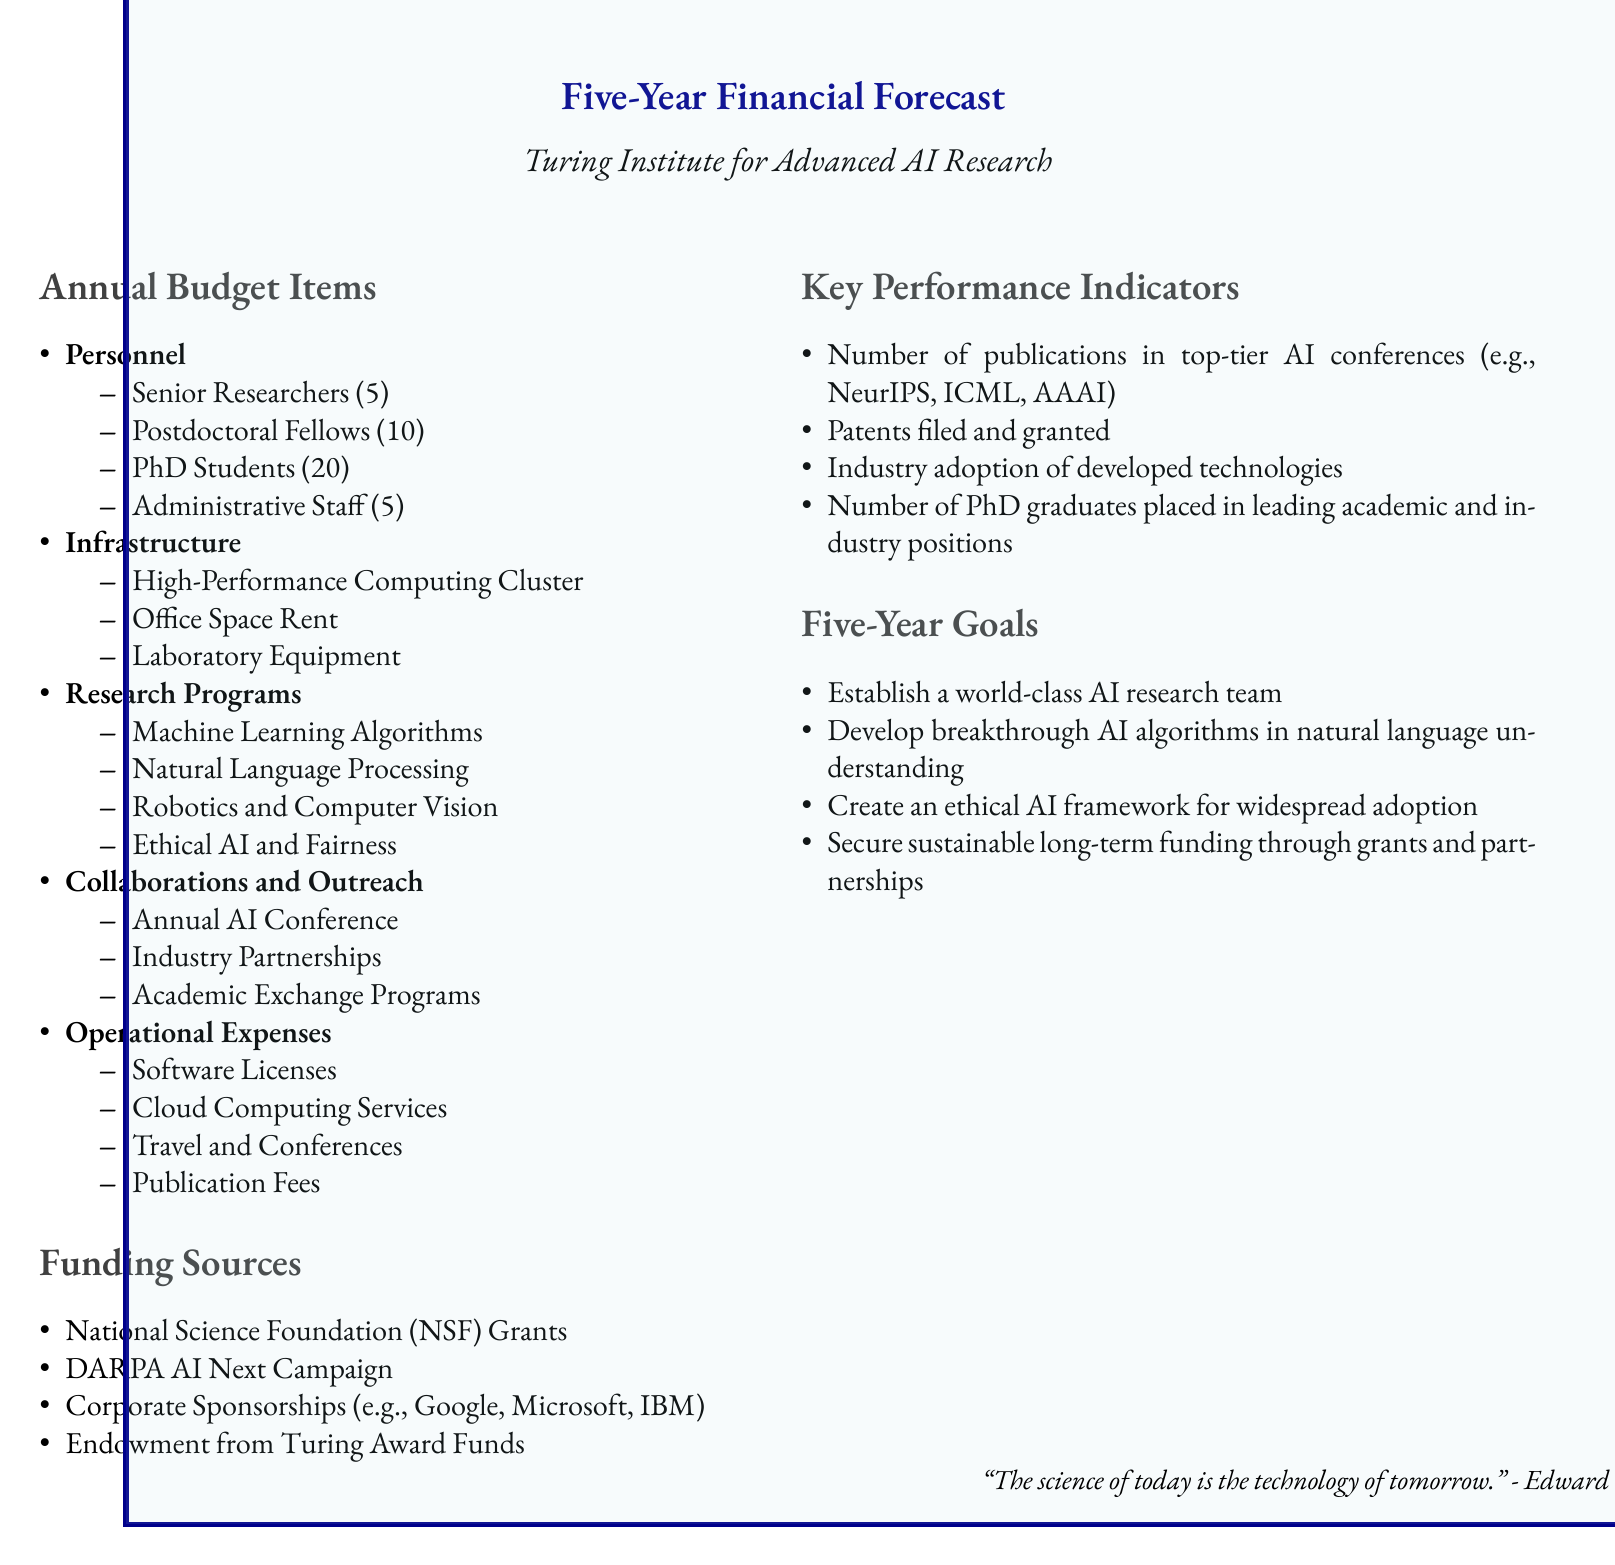What are the total number of administrative staff? The document lists the personnel section which indicates there are 5 administrative staff members.
Answer: 5 How many PhD students will be part of the institute? The document specifies that there will be 20 PhD students included in the personnel.
Answer: 20 What type of research program focuses on fairness in AI? The document includes a specific research program titled "Ethical AI and Fairness".
Answer: Ethical AI and Fairness What is one of the key performance indicators? One of the key performance indicators mentioned is the number of publications in top-tier AI conferences.
Answer: Number of publications Which funding source is mentioned last in the list? The document lists funding sources and the last one mentioned is "Endowment from Turing Award Funds."
Answer: Endowment from Turing Award Funds What is the goal related to PhD graduates? The document includes a goal which focuses on the placement of PhD graduates in leading academic and industry positions.
Answer: Number of PhD graduates placed What is the target for developing AI algorithms? The five-year goals include developing breakthrough AI algorithms in natural language understanding.
Answer: Breakthrough AI algorithms in natural language understanding Which organization provided the forecast title? The document shows the title states it was provided for the "Turing Institute for Advanced AI Research."
Answer: Turing Institute for Advanced AI Research How many high-performance computing items are listed under infrastructure? The infrastructure section mentions one item specifically, the "High-Performance Computing Cluster."
Answer: High-Performance Computing Cluster 